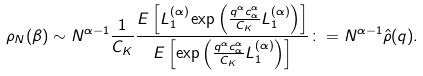Convert formula to latex. <formula><loc_0><loc_0><loc_500><loc_500>\rho _ { N } ( \beta ) \sim N ^ { \alpha - 1 } \frac { 1 } { C _ { K } } \frac { E \left [ L ^ { ( \alpha ) } _ { 1 } \exp \left ( \frac { q ^ { \alpha } c _ { \alpha } ^ { \alpha } } { C _ { K } } L ^ { ( \alpha ) } _ { 1 } \right ) \right ] } { E \left [ \exp \left ( \frac { q ^ { \alpha } c _ { \alpha } ^ { \alpha } } { C _ { K } } L ^ { ( \alpha ) } _ { 1 } \right ) \right ] } \colon = N ^ { \alpha - 1 } \hat { \rho } ( q ) .</formula> 